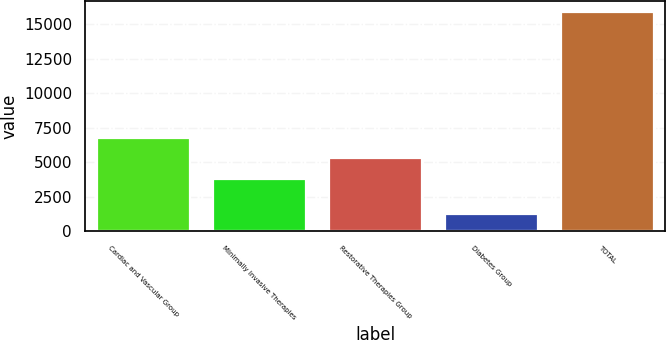Convert chart. <chart><loc_0><loc_0><loc_500><loc_500><bar_chart><fcel>Cardiac and Vascular Group<fcel>Minimally Invasive Therapies<fcel>Restorative Therapies Group<fcel>Diabetes Group<fcel>TOTAL<nl><fcel>6733.8<fcel>3804<fcel>5268.9<fcel>1226<fcel>15875<nl></chart> 